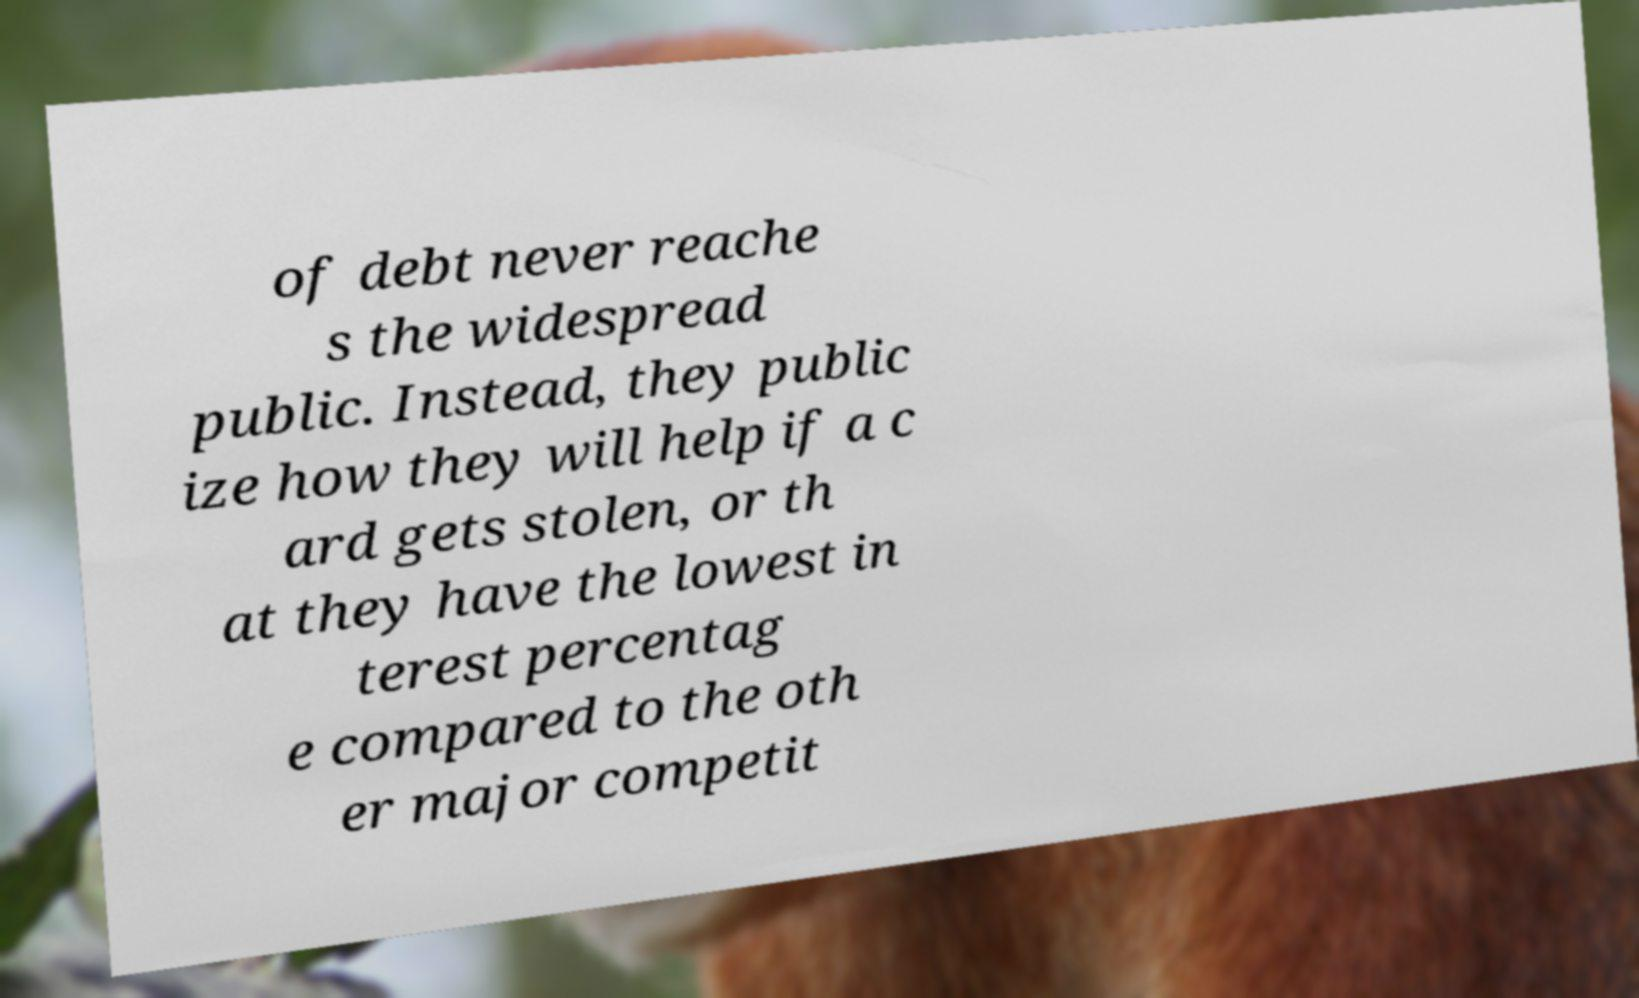Could you extract and type out the text from this image? of debt never reache s the widespread public. Instead, they public ize how they will help if a c ard gets stolen, or th at they have the lowest in terest percentag e compared to the oth er major competit 